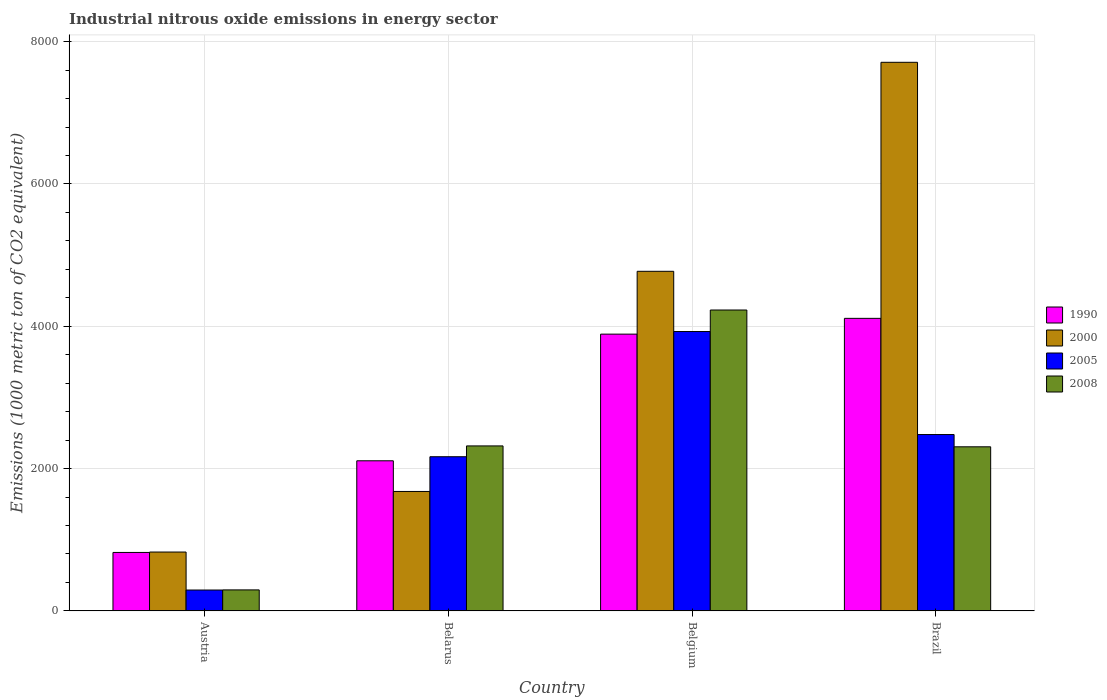How many groups of bars are there?
Ensure brevity in your answer.  4. Are the number of bars per tick equal to the number of legend labels?
Offer a terse response. Yes. Are the number of bars on each tick of the X-axis equal?
Your answer should be compact. Yes. What is the amount of industrial nitrous oxide emitted in 2000 in Brazil?
Your answer should be compact. 7709.7. Across all countries, what is the maximum amount of industrial nitrous oxide emitted in 2005?
Keep it short and to the point. 3926.3. Across all countries, what is the minimum amount of industrial nitrous oxide emitted in 2008?
Make the answer very short. 295.2. What is the total amount of industrial nitrous oxide emitted in 2008 in the graph?
Your response must be concise. 9148.7. What is the difference between the amount of industrial nitrous oxide emitted in 1990 in Belgium and that in Brazil?
Give a very brief answer. -221.8. What is the difference between the amount of industrial nitrous oxide emitted in 1990 in Austria and the amount of industrial nitrous oxide emitted in 2000 in Belgium?
Keep it short and to the point. -3951.1. What is the average amount of industrial nitrous oxide emitted in 1990 per country?
Give a very brief answer. 2733.02. What is the difference between the amount of industrial nitrous oxide emitted of/in 1990 and amount of industrial nitrous oxide emitted of/in 2005 in Belarus?
Ensure brevity in your answer.  -57.1. In how many countries, is the amount of industrial nitrous oxide emitted in 1990 greater than 2400 1000 metric ton?
Provide a succinct answer. 2. What is the ratio of the amount of industrial nitrous oxide emitted in 2008 in Belarus to that in Belgium?
Give a very brief answer. 0.55. Is the difference between the amount of industrial nitrous oxide emitted in 1990 in Belgium and Brazil greater than the difference between the amount of industrial nitrous oxide emitted in 2005 in Belgium and Brazil?
Give a very brief answer. No. What is the difference between the highest and the second highest amount of industrial nitrous oxide emitted in 1990?
Provide a short and direct response. 1780. What is the difference between the highest and the lowest amount of industrial nitrous oxide emitted in 2005?
Your response must be concise. 3633. In how many countries, is the amount of industrial nitrous oxide emitted in 2005 greater than the average amount of industrial nitrous oxide emitted in 2005 taken over all countries?
Give a very brief answer. 2. Is the sum of the amount of industrial nitrous oxide emitted in 2005 in Austria and Brazil greater than the maximum amount of industrial nitrous oxide emitted in 1990 across all countries?
Your answer should be very brief. No. What does the 4th bar from the right in Austria represents?
Your answer should be very brief. 1990. Is it the case that in every country, the sum of the amount of industrial nitrous oxide emitted in 2000 and amount of industrial nitrous oxide emitted in 2005 is greater than the amount of industrial nitrous oxide emitted in 1990?
Provide a succinct answer. Yes. How many bars are there?
Ensure brevity in your answer.  16. What is the difference between two consecutive major ticks on the Y-axis?
Keep it short and to the point. 2000. Does the graph contain any zero values?
Your response must be concise. No. Does the graph contain grids?
Ensure brevity in your answer.  Yes. How many legend labels are there?
Offer a terse response. 4. What is the title of the graph?
Offer a very short reply. Industrial nitrous oxide emissions in energy sector. Does "1975" appear as one of the legend labels in the graph?
Your answer should be compact. No. What is the label or title of the Y-axis?
Ensure brevity in your answer.  Emissions (1000 metric ton of CO2 equivalent). What is the Emissions (1000 metric ton of CO2 equivalent) in 1990 in Austria?
Make the answer very short. 821.5. What is the Emissions (1000 metric ton of CO2 equivalent) of 2000 in Austria?
Your answer should be compact. 827.2. What is the Emissions (1000 metric ton of CO2 equivalent) in 2005 in Austria?
Ensure brevity in your answer.  293.3. What is the Emissions (1000 metric ton of CO2 equivalent) in 2008 in Austria?
Your answer should be very brief. 295.2. What is the Emissions (1000 metric ton of CO2 equivalent) in 1990 in Belarus?
Offer a terse response. 2109.6. What is the Emissions (1000 metric ton of CO2 equivalent) in 2000 in Belarus?
Offer a very short reply. 1678.6. What is the Emissions (1000 metric ton of CO2 equivalent) of 2005 in Belarus?
Your answer should be compact. 2166.7. What is the Emissions (1000 metric ton of CO2 equivalent) in 2008 in Belarus?
Give a very brief answer. 2318.7. What is the Emissions (1000 metric ton of CO2 equivalent) of 1990 in Belgium?
Give a very brief answer. 3889.6. What is the Emissions (1000 metric ton of CO2 equivalent) in 2000 in Belgium?
Provide a succinct answer. 4772.6. What is the Emissions (1000 metric ton of CO2 equivalent) in 2005 in Belgium?
Keep it short and to the point. 3926.3. What is the Emissions (1000 metric ton of CO2 equivalent) in 2008 in Belgium?
Ensure brevity in your answer.  4228.6. What is the Emissions (1000 metric ton of CO2 equivalent) in 1990 in Brazil?
Provide a short and direct response. 4111.4. What is the Emissions (1000 metric ton of CO2 equivalent) in 2000 in Brazil?
Provide a short and direct response. 7709.7. What is the Emissions (1000 metric ton of CO2 equivalent) in 2005 in Brazil?
Your response must be concise. 2478.5. What is the Emissions (1000 metric ton of CO2 equivalent) of 2008 in Brazil?
Offer a terse response. 2306.2. Across all countries, what is the maximum Emissions (1000 metric ton of CO2 equivalent) in 1990?
Ensure brevity in your answer.  4111.4. Across all countries, what is the maximum Emissions (1000 metric ton of CO2 equivalent) of 2000?
Provide a succinct answer. 7709.7. Across all countries, what is the maximum Emissions (1000 metric ton of CO2 equivalent) in 2005?
Offer a terse response. 3926.3. Across all countries, what is the maximum Emissions (1000 metric ton of CO2 equivalent) in 2008?
Your answer should be compact. 4228.6. Across all countries, what is the minimum Emissions (1000 metric ton of CO2 equivalent) of 1990?
Offer a terse response. 821.5. Across all countries, what is the minimum Emissions (1000 metric ton of CO2 equivalent) in 2000?
Your response must be concise. 827.2. Across all countries, what is the minimum Emissions (1000 metric ton of CO2 equivalent) of 2005?
Offer a terse response. 293.3. Across all countries, what is the minimum Emissions (1000 metric ton of CO2 equivalent) in 2008?
Offer a very short reply. 295.2. What is the total Emissions (1000 metric ton of CO2 equivalent) of 1990 in the graph?
Your answer should be very brief. 1.09e+04. What is the total Emissions (1000 metric ton of CO2 equivalent) of 2000 in the graph?
Make the answer very short. 1.50e+04. What is the total Emissions (1000 metric ton of CO2 equivalent) of 2005 in the graph?
Provide a short and direct response. 8864.8. What is the total Emissions (1000 metric ton of CO2 equivalent) of 2008 in the graph?
Provide a short and direct response. 9148.7. What is the difference between the Emissions (1000 metric ton of CO2 equivalent) in 1990 in Austria and that in Belarus?
Offer a terse response. -1288.1. What is the difference between the Emissions (1000 metric ton of CO2 equivalent) in 2000 in Austria and that in Belarus?
Your response must be concise. -851.4. What is the difference between the Emissions (1000 metric ton of CO2 equivalent) in 2005 in Austria and that in Belarus?
Offer a terse response. -1873.4. What is the difference between the Emissions (1000 metric ton of CO2 equivalent) in 2008 in Austria and that in Belarus?
Your response must be concise. -2023.5. What is the difference between the Emissions (1000 metric ton of CO2 equivalent) in 1990 in Austria and that in Belgium?
Offer a very short reply. -3068.1. What is the difference between the Emissions (1000 metric ton of CO2 equivalent) in 2000 in Austria and that in Belgium?
Offer a terse response. -3945.4. What is the difference between the Emissions (1000 metric ton of CO2 equivalent) in 2005 in Austria and that in Belgium?
Provide a short and direct response. -3633. What is the difference between the Emissions (1000 metric ton of CO2 equivalent) in 2008 in Austria and that in Belgium?
Make the answer very short. -3933.4. What is the difference between the Emissions (1000 metric ton of CO2 equivalent) of 1990 in Austria and that in Brazil?
Offer a very short reply. -3289.9. What is the difference between the Emissions (1000 metric ton of CO2 equivalent) in 2000 in Austria and that in Brazil?
Your answer should be very brief. -6882.5. What is the difference between the Emissions (1000 metric ton of CO2 equivalent) of 2005 in Austria and that in Brazil?
Your response must be concise. -2185.2. What is the difference between the Emissions (1000 metric ton of CO2 equivalent) of 2008 in Austria and that in Brazil?
Keep it short and to the point. -2011. What is the difference between the Emissions (1000 metric ton of CO2 equivalent) in 1990 in Belarus and that in Belgium?
Offer a terse response. -1780. What is the difference between the Emissions (1000 metric ton of CO2 equivalent) in 2000 in Belarus and that in Belgium?
Your answer should be compact. -3094. What is the difference between the Emissions (1000 metric ton of CO2 equivalent) in 2005 in Belarus and that in Belgium?
Ensure brevity in your answer.  -1759.6. What is the difference between the Emissions (1000 metric ton of CO2 equivalent) of 2008 in Belarus and that in Belgium?
Give a very brief answer. -1909.9. What is the difference between the Emissions (1000 metric ton of CO2 equivalent) in 1990 in Belarus and that in Brazil?
Your answer should be compact. -2001.8. What is the difference between the Emissions (1000 metric ton of CO2 equivalent) in 2000 in Belarus and that in Brazil?
Provide a short and direct response. -6031.1. What is the difference between the Emissions (1000 metric ton of CO2 equivalent) of 2005 in Belarus and that in Brazil?
Your response must be concise. -311.8. What is the difference between the Emissions (1000 metric ton of CO2 equivalent) in 1990 in Belgium and that in Brazil?
Make the answer very short. -221.8. What is the difference between the Emissions (1000 metric ton of CO2 equivalent) in 2000 in Belgium and that in Brazil?
Your answer should be very brief. -2937.1. What is the difference between the Emissions (1000 metric ton of CO2 equivalent) of 2005 in Belgium and that in Brazil?
Ensure brevity in your answer.  1447.8. What is the difference between the Emissions (1000 metric ton of CO2 equivalent) of 2008 in Belgium and that in Brazil?
Provide a short and direct response. 1922.4. What is the difference between the Emissions (1000 metric ton of CO2 equivalent) in 1990 in Austria and the Emissions (1000 metric ton of CO2 equivalent) in 2000 in Belarus?
Give a very brief answer. -857.1. What is the difference between the Emissions (1000 metric ton of CO2 equivalent) in 1990 in Austria and the Emissions (1000 metric ton of CO2 equivalent) in 2005 in Belarus?
Provide a short and direct response. -1345.2. What is the difference between the Emissions (1000 metric ton of CO2 equivalent) of 1990 in Austria and the Emissions (1000 metric ton of CO2 equivalent) of 2008 in Belarus?
Offer a very short reply. -1497.2. What is the difference between the Emissions (1000 metric ton of CO2 equivalent) in 2000 in Austria and the Emissions (1000 metric ton of CO2 equivalent) in 2005 in Belarus?
Provide a succinct answer. -1339.5. What is the difference between the Emissions (1000 metric ton of CO2 equivalent) in 2000 in Austria and the Emissions (1000 metric ton of CO2 equivalent) in 2008 in Belarus?
Provide a succinct answer. -1491.5. What is the difference between the Emissions (1000 metric ton of CO2 equivalent) in 2005 in Austria and the Emissions (1000 metric ton of CO2 equivalent) in 2008 in Belarus?
Offer a very short reply. -2025.4. What is the difference between the Emissions (1000 metric ton of CO2 equivalent) in 1990 in Austria and the Emissions (1000 metric ton of CO2 equivalent) in 2000 in Belgium?
Keep it short and to the point. -3951.1. What is the difference between the Emissions (1000 metric ton of CO2 equivalent) of 1990 in Austria and the Emissions (1000 metric ton of CO2 equivalent) of 2005 in Belgium?
Give a very brief answer. -3104.8. What is the difference between the Emissions (1000 metric ton of CO2 equivalent) of 1990 in Austria and the Emissions (1000 metric ton of CO2 equivalent) of 2008 in Belgium?
Make the answer very short. -3407.1. What is the difference between the Emissions (1000 metric ton of CO2 equivalent) in 2000 in Austria and the Emissions (1000 metric ton of CO2 equivalent) in 2005 in Belgium?
Ensure brevity in your answer.  -3099.1. What is the difference between the Emissions (1000 metric ton of CO2 equivalent) of 2000 in Austria and the Emissions (1000 metric ton of CO2 equivalent) of 2008 in Belgium?
Provide a short and direct response. -3401.4. What is the difference between the Emissions (1000 metric ton of CO2 equivalent) of 2005 in Austria and the Emissions (1000 metric ton of CO2 equivalent) of 2008 in Belgium?
Your answer should be very brief. -3935.3. What is the difference between the Emissions (1000 metric ton of CO2 equivalent) in 1990 in Austria and the Emissions (1000 metric ton of CO2 equivalent) in 2000 in Brazil?
Ensure brevity in your answer.  -6888.2. What is the difference between the Emissions (1000 metric ton of CO2 equivalent) in 1990 in Austria and the Emissions (1000 metric ton of CO2 equivalent) in 2005 in Brazil?
Ensure brevity in your answer.  -1657. What is the difference between the Emissions (1000 metric ton of CO2 equivalent) of 1990 in Austria and the Emissions (1000 metric ton of CO2 equivalent) of 2008 in Brazil?
Make the answer very short. -1484.7. What is the difference between the Emissions (1000 metric ton of CO2 equivalent) of 2000 in Austria and the Emissions (1000 metric ton of CO2 equivalent) of 2005 in Brazil?
Your response must be concise. -1651.3. What is the difference between the Emissions (1000 metric ton of CO2 equivalent) of 2000 in Austria and the Emissions (1000 metric ton of CO2 equivalent) of 2008 in Brazil?
Your response must be concise. -1479. What is the difference between the Emissions (1000 metric ton of CO2 equivalent) of 2005 in Austria and the Emissions (1000 metric ton of CO2 equivalent) of 2008 in Brazil?
Provide a short and direct response. -2012.9. What is the difference between the Emissions (1000 metric ton of CO2 equivalent) of 1990 in Belarus and the Emissions (1000 metric ton of CO2 equivalent) of 2000 in Belgium?
Give a very brief answer. -2663. What is the difference between the Emissions (1000 metric ton of CO2 equivalent) of 1990 in Belarus and the Emissions (1000 metric ton of CO2 equivalent) of 2005 in Belgium?
Your answer should be compact. -1816.7. What is the difference between the Emissions (1000 metric ton of CO2 equivalent) of 1990 in Belarus and the Emissions (1000 metric ton of CO2 equivalent) of 2008 in Belgium?
Ensure brevity in your answer.  -2119. What is the difference between the Emissions (1000 metric ton of CO2 equivalent) of 2000 in Belarus and the Emissions (1000 metric ton of CO2 equivalent) of 2005 in Belgium?
Give a very brief answer. -2247.7. What is the difference between the Emissions (1000 metric ton of CO2 equivalent) of 2000 in Belarus and the Emissions (1000 metric ton of CO2 equivalent) of 2008 in Belgium?
Provide a succinct answer. -2550. What is the difference between the Emissions (1000 metric ton of CO2 equivalent) in 2005 in Belarus and the Emissions (1000 metric ton of CO2 equivalent) in 2008 in Belgium?
Make the answer very short. -2061.9. What is the difference between the Emissions (1000 metric ton of CO2 equivalent) of 1990 in Belarus and the Emissions (1000 metric ton of CO2 equivalent) of 2000 in Brazil?
Your answer should be very brief. -5600.1. What is the difference between the Emissions (1000 metric ton of CO2 equivalent) of 1990 in Belarus and the Emissions (1000 metric ton of CO2 equivalent) of 2005 in Brazil?
Make the answer very short. -368.9. What is the difference between the Emissions (1000 metric ton of CO2 equivalent) of 1990 in Belarus and the Emissions (1000 metric ton of CO2 equivalent) of 2008 in Brazil?
Offer a terse response. -196.6. What is the difference between the Emissions (1000 metric ton of CO2 equivalent) in 2000 in Belarus and the Emissions (1000 metric ton of CO2 equivalent) in 2005 in Brazil?
Offer a very short reply. -799.9. What is the difference between the Emissions (1000 metric ton of CO2 equivalent) of 2000 in Belarus and the Emissions (1000 metric ton of CO2 equivalent) of 2008 in Brazil?
Make the answer very short. -627.6. What is the difference between the Emissions (1000 metric ton of CO2 equivalent) of 2005 in Belarus and the Emissions (1000 metric ton of CO2 equivalent) of 2008 in Brazil?
Make the answer very short. -139.5. What is the difference between the Emissions (1000 metric ton of CO2 equivalent) in 1990 in Belgium and the Emissions (1000 metric ton of CO2 equivalent) in 2000 in Brazil?
Provide a succinct answer. -3820.1. What is the difference between the Emissions (1000 metric ton of CO2 equivalent) of 1990 in Belgium and the Emissions (1000 metric ton of CO2 equivalent) of 2005 in Brazil?
Keep it short and to the point. 1411.1. What is the difference between the Emissions (1000 metric ton of CO2 equivalent) of 1990 in Belgium and the Emissions (1000 metric ton of CO2 equivalent) of 2008 in Brazil?
Keep it short and to the point. 1583.4. What is the difference between the Emissions (1000 metric ton of CO2 equivalent) in 2000 in Belgium and the Emissions (1000 metric ton of CO2 equivalent) in 2005 in Brazil?
Provide a succinct answer. 2294.1. What is the difference between the Emissions (1000 metric ton of CO2 equivalent) of 2000 in Belgium and the Emissions (1000 metric ton of CO2 equivalent) of 2008 in Brazil?
Provide a succinct answer. 2466.4. What is the difference between the Emissions (1000 metric ton of CO2 equivalent) of 2005 in Belgium and the Emissions (1000 metric ton of CO2 equivalent) of 2008 in Brazil?
Your response must be concise. 1620.1. What is the average Emissions (1000 metric ton of CO2 equivalent) in 1990 per country?
Give a very brief answer. 2733.03. What is the average Emissions (1000 metric ton of CO2 equivalent) in 2000 per country?
Ensure brevity in your answer.  3747.03. What is the average Emissions (1000 metric ton of CO2 equivalent) in 2005 per country?
Your answer should be very brief. 2216.2. What is the average Emissions (1000 metric ton of CO2 equivalent) of 2008 per country?
Keep it short and to the point. 2287.18. What is the difference between the Emissions (1000 metric ton of CO2 equivalent) in 1990 and Emissions (1000 metric ton of CO2 equivalent) in 2000 in Austria?
Offer a very short reply. -5.7. What is the difference between the Emissions (1000 metric ton of CO2 equivalent) in 1990 and Emissions (1000 metric ton of CO2 equivalent) in 2005 in Austria?
Keep it short and to the point. 528.2. What is the difference between the Emissions (1000 metric ton of CO2 equivalent) in 1990 and Emissions (1000 metric ton of CO2 equivalent) in 2008 in Austria?
Give a very brief answer. 526.3. What is the difference between the Emissions (1000 metric ton of CO2 equivalent) in 2000 and Emissions (1000 metric ton of CO2 equivalent) in 2005 in Austria?
Ensure brevity in your answer.  533.9. What is the difference between the Emissions (1000 metric ton of CO2 equivalent) in 2000 and Emissions (1000 metric ton of CO2 equivalent) in 2008 in Austria?
Your answer should be compact. 532. What is the difference between the Emissions (1000 metric ton of CO2 equivalent) in 2005 and Emissions (1000 metric ton of CO2 equivalent) in 2008 in Austria?
Offer a terse response. -1.9. What is the difference between the Emissions (1000 metric ton of CO2 equivalent) in 1990 and Emissions (1000 metric ton of CO2 equivalent) in 2000 in Belarus?
Provide a succinct answer. 431. What is the difference between the Emissions (1000 metric ton of CO2 equivalent) in 1990 and Emissions (1000 metric ton of CO2 equivalent) in 2005 in Belarus?
Provide a short and direct response. -57.1. What is the difference between the Emissions (1000 metric ton of CO2 equivalent) in 1990 and Emissions (1000 metric ton of CO2 equivalent) in 2008 in Belarus?
Provide a short and direct response. -209.1. What is the difference between the Emissions (1000 metric ton of CO2 equivalent) of 2000 and Emissions (1000 metric ton of CO2 equivalent) of 2005 in Belarus?
Offer a very short reply. -488.1. What is the difference between the Emissions (1000 metric ton of CO2 equivalent) in 2000 and Emissions (1000 metric ton of CO2 equivalent) in 2008 in Belarus?
Your response must be concise. -640.1. What is the difference between the Emissions (1000 metric ton of CO2 equivalent) in 2005 and Emissions (1000 metric ton of CO2 equivalent) in 2008 in Belarus?
Make the answer very short. -152. What is the difference between the Emissions (1000 metric ton of CO2 equivalent) in 1990 and Emissions (1000 metric ton of CO2 equivalent) in 2000 in Belgium?
Keep it short and to the point. -883. What is the difference between the Emissions (1000 metric ton of CO2 equivalent) in 1990 and Emissions (1000 metric ton of CO2 equivalent) in 2005 in Belgium?
Ensure brevity in your answer.  -36.7. What is the difference between the Emissions (1000 metric ton of CO2 equivalent) in 1990 and Emissions (1000 metric ton of CO2 equivalent) in 2008 in Belgium?
Your answer should be very brief. -339. What is the difference between the Emissions (1000 metric ton of CO2 equivalent) of 2000 and Emissions (1000 metric ton of CO2 equivalent) of 2005 in Belgium?
Give a very brief answer. 846.3. What is the difference between the Emissions (1000 metric ton of CO2 equivalent) of 2000 and Emissions (1000 metric ton of CO2 equivalent) of 2008 in Belgium?
Your response must be concise. 544. What is the difference between the Emissions (1000 metric ton of CO2 equivalent) in 2005 and Emissions (1000 metric ton of CO2 equivalent) in 2008 in Belgium?
Offer a terse response. -302.3. What is the difference between the Emissions (1000 metric ton of CO2 equivalent) of 1990 and Emissions (1000 metric ton of CO2 equivalent) of 2000 in Brazil?
Provide a short and direct response. -3598.3. What is the difference between the Emissions (1000 metric ton of CO2 equivalent) in 1990 and Emissions (1000 metric ton of CO2 equivalent) in 2005 in Brazil?
Provide a succinct answer. 1632.9. What is the difference between the Emissions (1000 metric ton of CO2 equivalent) of 1990 and Emissions (1000 metric ton of CO2 equivalent) of 2008 in Brazil?
Your answer should be compact. 1805.2. What is the difference between the Emissions (1000 metric ton of CO2 equivalent) in 2000 and Emissions (1000 metric ton of CO2 equivalent) in 2005 in Brazil?
Ensure brevity in your answer.  5231.2. What is the difference between the Emissions (1000 metric ton of CO2 equivalent) of 2000 and Emissions (1000 metric ton of CO2 equivalent) of 2008 in Brazil?
Give a very brief answer. 5403.5. What is the difference between the Emissions (1000 metric ton of CO2 equivalent) in 2005 and Emissions (1000 metric ton of CO2 equivalent) in 2008 in Brazil?
Give a very brief answer. 172.3. What is the ratio of the Emissions (1000 metric ton of CO2 equivalent) in 1990 in Austria to that in Belarus?
Your answer should be very brief. 0.39. What is the ratio of the Emissions (1000 metric ton of CO2 equivalent) in 2000 in Austria to that in Belarus?
Your answer should be very brief. 0.49. What is the ratio of the Emissions (1000 metric ton of CO2 equivalent) of 2005 in Austria to that in Belarus?
Your answer should be very brief. 0.14. What is the ratio of the Emissions (1000 metric ton of CO2 equivalent) of 2008 in Austria to that in Belarus?
Ensure brevity in your answer.  0.13. What is the ratio of the Emissions (1000 metric ton of CO2 equivalent) of 1990 in Austria to that in Belgium?
Make the answer very short. 0.21. What is the ratio of the Emissions (1000 metric ton of CO2 equivalent) of 2000 in Austria to that in Belgium?
Your response must be concise. 0.17. What is the ratio of the Emissions (1000 metric ton of CO2 equivalent) in 2005 in Austria to that in Belgium?
Your answer should be very brief. 0.07. What is the ratio of the Emissions (1000 metric ton of CO2 equivalent) of 2008 in Austria to that in Belgium?
Provide a short and direct response. 0.07. What is the ratio of the Emissions (1000 metric ton of CO2 equivalent) in 1990 in Austria to that in Brazil?
Offer a very short reply. 0.2. What is the ratio of the Emissions (1000 metric ton of CO2 equivalent) of 2000 in Austria to that in Brazil?
Your response must be concise. 0.11. What is the ratio of the Emissions (1000 metric ton of CO2 equivalent) of 2005 in Austria to that in Brazil?
Provide a short and direct response. 0.12. What is the ratio of the Emissions (1000 metric ton of CO2 equivalent) in 2008 in Austria to that in Brazil?
Offer a terse response. 0.13. What is the ratio of the Emissions (1000 metric ton of CO2 equivalent) of 1990 in Belarus to that in Belgium?
Your answer should be compact. 0.54. What is the ratio of the Emissions (1000 metric ton of CO2 equivalent) of 2000 in Belarus to that in Belgium?
Offer a terse response. 0.35. What is the ratio of the Emissions (1000 metric ton of CO2 equivalent) in 2005 in Belarus to that in Belgium?
Make the answer very short. 0.55. What is the ratio of the Emissions (1000 metric ton of CO2 equivalent) in 2008 in Belarus to that in Belgium?
Ensure brevity in your answer.  0.55. What is the ratio of the Emissions (1000 metric ton of CO2 equivalent) of 1990 in Belarus to that in Brazil?
Offer a terse response. 0.51. What is the ratio of the Emissions (1000 metric ton of CO2 equivalent) of 2000 in Belarus to that in Brazil?
Offer a very short reply. 0.22. What is the ratio of the Emissions (1000 metric ton of CO2 equivalent) of 2005 in Belarus to that in Brazil?
Give a very brief answer. 0.87. What is the ratio of the Emissions (1000 metric ton of CO2 equivalent) of 2008 in Belarus to that in Brazil?
Your answer should be compact. 1.01. What is the ratio of the Emissions (1000 metric ton of CO2 equivalent) of 1990 in Belgium to that in Brazil?
Ensure brevity in your answer.  0.95. What is the ratio of the Emissions (1000 metric ton of CO2 equivalent) in 2000 in Belgium to that in Brazil?
Provide a succinct answer. 0.62. What is the ratio of the Emissions (1000 metric ton of CO2 equivalent) in 2005 in Belgium to that in Brazil?
Keep it short and to the point. 1.58. What is the ratio of the Emissions (1000 metric ton of CO2 equivalent) of 2008 in Belgium to that in Brazil?
Your answer should be very brief. 1.83. What is the difference between the highest and the second highest Emissions (1000 metric ton of CO2 equivalent) in 1990?
Ensure brevity in your answer.  221.8. What is the difference between the highest and the second highest Emissions (1000 metric ton of CO2 equivalent) in 2000?
Your answer should be compact. 2937.1. What is the difference between the highest and the second highest Emissions (1000 metric ton of CO2 equivalent) of 2005?
Your answer should be compact. 1447.8. What is the difference between the highest and the second highest Emissions (1000 metric ton of CO2 equivalent) of 2008?
Make the answer very short. 1909.9. What is the difference between the highest and the lowest Emissions (1000 metric ton of CO2 equivalent) of 1990?
Provide a short and direct response. 3289.9. What is the difference between the highest and the lowest Emissions (1000 metric ton of CO2 equivalent) in 2000?
Your answer should be compact. 6882.5. What is the difference between the highest and the lowest Emissions (1000 metric ton of CO2 equivalent) of 2005?
Offer a terse response. 3633. What is the difference between the highest and the lowest Emissions (1000 metric ton of CO2 equivalent) in 2008?
Ensure brevity in your answer.  3933.4. 